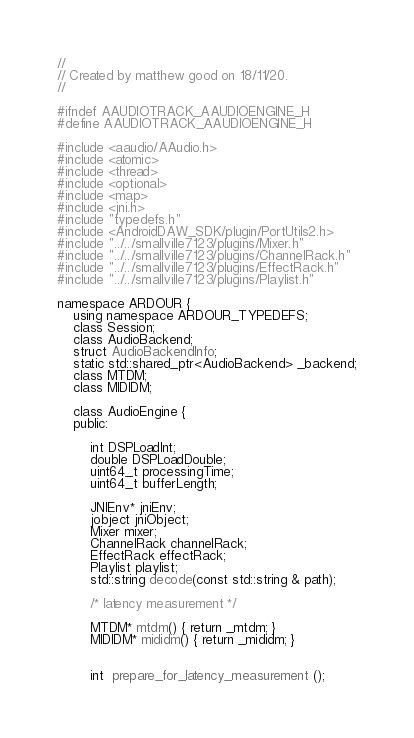<code> <loc_0><loc_0><loc_500><loc_500><_C_>//
// Created by matthew good on 18/11/20.
//

#ifndef AAUDIOTRACK_AAUDIOENGINE_H
#define AAUDIOTRACK_AAUDIOENGINE_H

#include <aaudio/AAudio.h>
#include <atomic>
#include <thread>
#include <optional>
#include <map>
#include <jni.h>
#include "typedefs.h"
#include <AndroidDAW_SDK/plugin/PortUtils2.h>
#include "../../smallville7123/plugins/Mixer.h"
#include "../../smallville7123/plugins/ChannelRack.h"
#include "../../smallville7123/plugins/EffectRack.h"
#include "../../smallville7123/plugins/Playlist.h"

namespace ARDOUR {
    using namespace ARDOUR_TYPEDEFS;
    class Session;
    class AudioBackend;
    struct AudioBackendInfo;
    static std::shared_ptr<AudioBackend> _backend;
    class MTDM;
    class MIDIDM;

    class AudioEngine {
    public:

        int DSPLoadInt;
        double DSPLoadDouble;
        uint64_t processingTime;
        uint64_t bufferLength;

        JNIEnv* jniEnv;
        jobject jniObject;
        Mixer mixer;
        ChannelRack channelRack;
        EffectRack effectRack;
        Playlist playlist;
        std::string decode(const std::string & path);

        /* latency measurement */

        MTDM* mtdm() { return _mtdm; }
        MIDIDM* mididm() { return _mididm; }


        int  prepare_for_latency_measurement ();</code> 